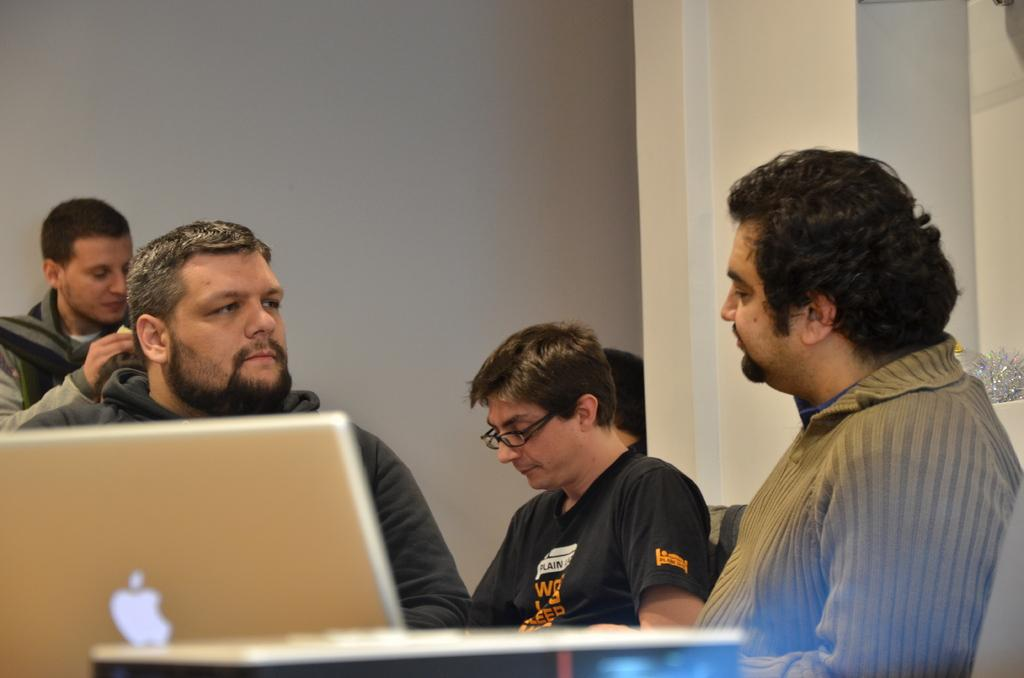What are the people in the image doing? There are persons sitting in the image. What electronic device can be seen in the image? There is a laptop in the left corner of the image. Can you describe any other objects visible in the background of the image? Unfortunately, the provided facts do not give specific details about the objects in the background. What type of lettuce can be seen growing in the image? There is no lettuce present in the image. How many leaves are visible on the leafy plant in the image? There is no leafy plant present in the image. 